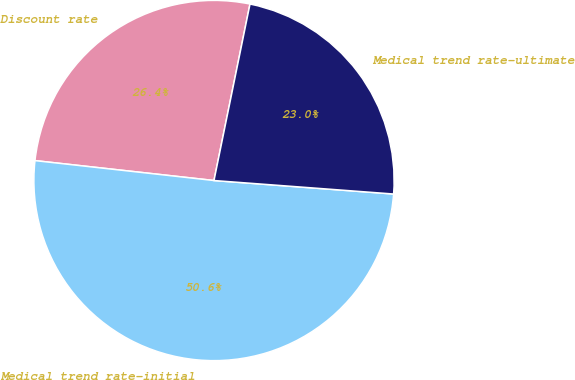Convert chart. <chart><loc_0><loc_0><loc_500><loc_500><pie_chart><fcel>Discount rate<fcel>Medical trend rate-initial<fcel>Medical trend rate-ultimate<nl><fcel>26.44%<fcel>50.57%<fcel>22.99%<nl></chart> 